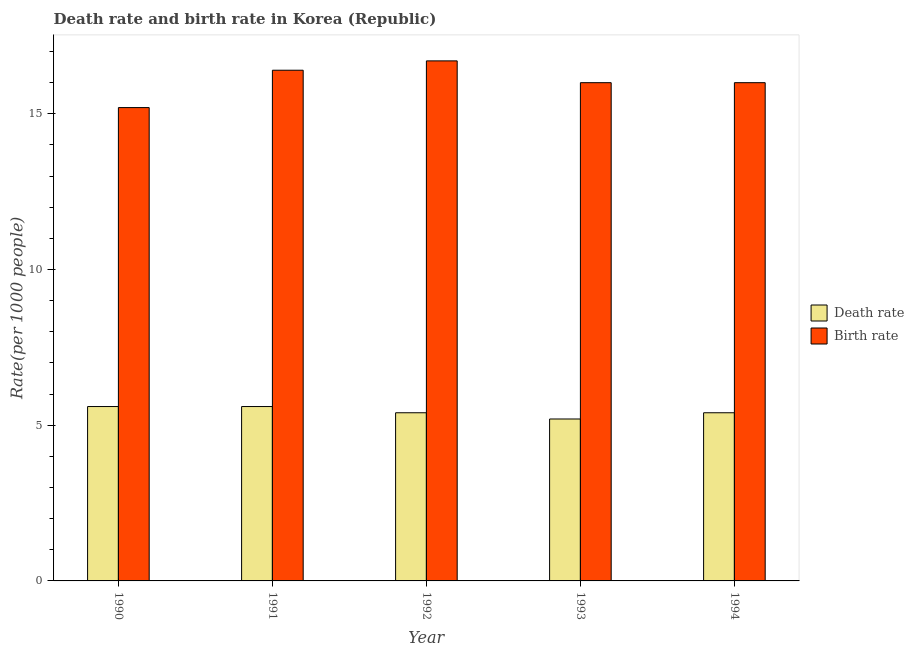How many different coloured bars are there?
Offer a very short reply. 2. How many groups of bars are there?
Provide a short and direct response. 5. Are the number of bars on each tick of the X-axis equal?
Your answer should be compact. Yes. How many bars are there on the 1st tick from the left?
Ensure brevity in your answer.  2. In how many cases, is the number of bars for a given year not equal to the number of legend labels?
Give a very brief answer. 0. In which year was the death rate minimum?
Your answer should be compact. 1993. What is the total death rate in the graph?
Your answer should be very brief. 27.2. What is the difference between the death rate in 1992 and that in 1993?
Offer a terse response. 0.2. What is the average death rate per year?
Offer a very short reply. 5.44. In the year 1991, what is the difference between the death rate and birth rate?
Offer a very short reply. 0. What is the ratio of the death rate in 1993 to that in 1994?
Provide a succinct answer. 0.96. Is the birth rate in 1990 less than that in 1993?
Provide a short and direct response. Yes. Is the difference between the death rate in 1990 and 1991 greater than the difference between the birth rate in 1990 and 1991?
Provide a succinct answer. No. Is the sum of the death rate in 1990 and 1993 greater than the maximum birth rate across all years?
Offer a terse response. Yes. What does the 2nd bar from the left in 1994 represents?
Provide a short and direct response. Birth rate. What does the 1st bar from the right in 1994 represents?
Make the answer very short. Birth rate. Are all the bars in the graph horizontal?
Make the answer very short. No. What is the difference between two consecutive major ticks on the Y-axis?
Ensure brevity in your answer.  5. Are the values on the major ticks of Y-axis written in scientific E-notation?
Your answer should be compact. No. How many legend labels are there?
Provide a succinct answer. 2. How are the legend labels stacked?
Your answer should be compact. Vertical. What is the title of the graph?
Your response must be concise. Death rate and birth rate in Korea (Republic). Does "Secondary" appear as one of the legend labels in the graph?
Offer a very short reply. No. What is the label or title of the Y-axis?
Keep it short and to the point. Rate(per 1000 people). What is the Rate(per 1000 people) of Birth rate in 1990?
Make the answer very short. 15.2. What is the Rate(per 1000 people) of Death rate in 1992?
Give a very brief answer. 5.4. What is the Rate(per 1000 people) of Birth rate in 1992?
Ensure brevity in your answer.  16.7. What is the Rate(per 1000 people) of Birth rate in 1993?
Provide a succinct answer. 16. What is the Rate(per 1000 people) of Birth rate in 1994?
Offer a terse response. 16. Across all years, what is the maximum Rate(per 1000 people) in Death rate?
Offer a terse response. 5.6. Across all years, what is the minimum Rate(per 1000 people) of Birth rate?
Give a very brief answer. 15.2. What is the total Rate(per 1000 people) in Death rate in the graph?
Keep it short and to the point. 27.2. What is the total Rate(per 1000 people) of Birth rate in the graph?
Ensure brevity in your answer.  80.3. What is the difference between the Rate(per 1000 people) in Birth rate in 1990 and that in 1991?
Offer a terse response. -1.2. What is the difference between the Rate(per 1000 people) in Death rate in 1990 and that in 1993?
Your answer should be very brief. 0.4. What is the difference between the Rate(per 1000 people) of Death rate in 1990 and that in 1994?
Your answer should be compact. 0.2. What is the difference between the Rate(per 1000 people) in Birth rate in 1990 and that in 1994?
Ensure brevity in your answer.  -0.8. What is the difference between the Rate(per 1000 people) in Birth rate in 1991 and that in 1992?
Offer a very short reply. -0.3. What is the difference between the Rate(per 1000 people) of Death rate in 1991 and that in 1993?
Give a very brief answer. 0.4. What is the difference between the Rate(per 1000 people) in Birth rate in 1991 and that in 1993?
Offer a terse response. 0.4. What is the difference between the Rate(per 1000 people) in Death rate in 1991 and that in 1994?
Your answer should be very brief. 0.2. What is the difference between the Rate(per 1000 people) of Birth rate in 1991 and that in 1994?
Keep it short and to the point. 0.4. What is the difference between the Rate(per 1000 people) in Death rate in 1992 and that in 1993?
Your answer should be very brief. 0.2. What is the difference between the Rate(per 1000 people) of Birth rate in 1992 and that in 1993?
Provide a succinct answer. 0.7. What is the difference between the Rate(per 1000 people) in Death rate in 1992 and that in 1994?
Give a very brief answer. 0. What is the difference between the Rate(per 1000 people) of Birth rate in 1992 and that in 1994?
Provide a succinct answer. 0.7. What is the difference between the Rate(per 1000 people) in Death rate in 1990 and the Rate(per 1000 people) in Birth rate in 1992?
Make the answer very short. -11.1. What is the difference between the Rate(per 1000 people) in Death rate in 1991 and the Rate(per 1000 people) in Birth rate in 1992?
Offer a terse response. -11.1. What is the difference between the Rate(per 1000 people) of Death rate in 1992 and the Rate(per 1000 people) of Birth rate in 1994?
Ensure brevity in your answer.  -10.6. What is the average Rate(per 1000 people) of Death rate per year?
Your answer should be compact. 5.44. What is the average Rate(per 1000 people) in Birth rate per year?
Offer a very short reply. 16.06. In the year 1991, what is the difference between the Rate(per 1000 people) of Death rate and Rate(per 1000 people) of Birth rate?
Provide a succinct answer. -10.8. In the year 1992, what is the difference between the Rate(per 1000 people) in Death rate and Rate(per 1000 people) in Birth rate?
Offer a terse response. -11.3. What is the ratio of the Rate(per 1000 people) in Death rate in 1990 to that in 1991?
Ensure brevity in your answer.  1. What is the ratio of the Rate(per 1000 people) in Birth rate in 1990 to that in 1991?
Your answer should be very brief. 0.93. What is the ratio of the Rate(per 1000 people) in Death rate in 1990 to that in 1992?
Make the answer very short. 1.04. What is the ratio of the Rate(per 1000 people) of Birth rate in 1990 to that in 1992?
Make the answer very short. 0.91. What is the ratio of the Rate(per 1000 people) in Death rate in 1990 to that in 1993?
Your response must be concise. 1.08. What is the ratio of the Rate(per 1000 people) in Death rate in 1990 to that in 1994?
Offer a very short reply. 1.04. What is the ratio of the Rate(per 1000 people) of Death rate in 1991 to that in 1992?
Give a very brief answer. 1.04. What is the ratio of the Rate(per 1000 people) in Birth rate in 1991 to that in 1992?
Provide a short and direct response. 0.98. What is the ratio of the Rate(per 1000 people) of Death rate in 1991 to that in 1993?
Provide a short and direct response. 1.08. What is the ratio of the Rate(per 1000 people) of Death rate in 1991 to that in 1994?
Offer a very short reply. 1.04. What is the ratio of the Rate(per 1000 people) of Birth rate in 1991 to that in 1994?
Keep it short and to the point. 1.02. What is the ratio of the Rate(per 1000 people) of Birth rate in 1992 to that in 1993?
Make the answer very short. 1.04. What is the ratio of the Rate(per 1000 people) of Birth rate in 1992 to that in 1994?
Your answer should be compact. 1.04. What is the ratio of the Rate(per 1000 people) of Death rate in 1993 to that in 1994?
Give a very brief answer. 0.96. What is the ratio of the Rate(per 1000 people) of Birth rate in 1993 to that in 1994?
Make the answer very short. 1. What is the difference between the highest and the second highest Rate(per 1000 people) in Death rate?
Ensure brevity in your answer.  0. What is the difference between the highest and the second highest Rate(per 1000 people) in Birth rate?
Your response must be concise. 0.3. What is the difference between the highest and the lowest Rate(per 1000 people) of Death rate?
Your answer should be very brief. 0.4. What is the difference between the highest and the lowest Rate(per 1000 people) of Birth rate?
Offer a terse response. 1.5. 